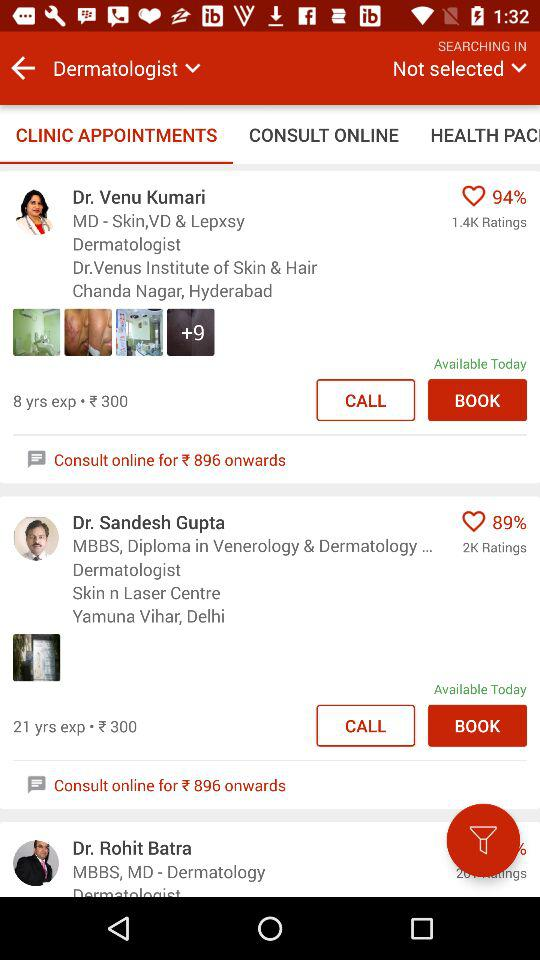What is the profession of Dr. Rohit Batra?
When the provided information is insufficient, respond with <no answer>. <no answer> 